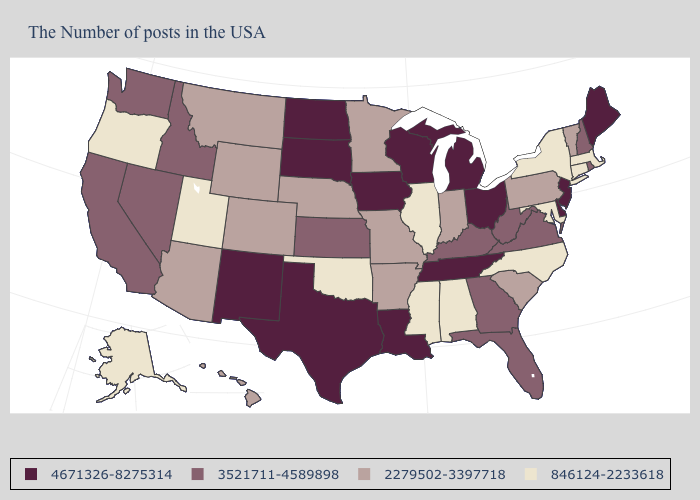What is the highest value in the South ?
Give a very brief answer. 4671326-8275314. Name the states that have a value in the range 846124-2233618?
Give a very brief answer. Massachusetts, Connecticut, New York, Maryland, North Carolina, Alabama, Illinois, Mississippi, Oklahoma, Utah, Oregon, Alaska. What is the highest value in the USA?
Concise answer only. 4671326-8275314. Name the states that have a value in the range 846124-2233618?
Short answer required. Massachusetts, Connecticut, New York, Maryland, North Carolina, Alabama, Illinois, Mississippi, Oklahoma, Utah, Oregon, Alaska. Does the map have missing data?
Write a very short answer. No. What is the value of Oklahoma?
Keep it brief. 846124-2233618. What is the value of Tennessee?
Be succinct. 4671326-8275314. Is the legend a continuous bar?
Answer briefly. No. Does Nebraska have a higher value than Alaska?
Keep it brief. Yes. Which states have the highest value in the USA?
Keep it brief. Maine, New Jersey, Delaware, Ohio, Michigan, Tennessee, Wisconsin, Louisiana, Iowa, Texas, South Dakota, North Dakota, New Mexico. What is the lowest value in the South?
Write a very short answer. 846124-2233618. What is the value of New Mexico?
Write a very short answer. 4671326-8275314. Name the states that have a value in the range 3521711-4589898?
Concise answer only. Rhode Island, New Hampshire, Virginia, West Virginia, Florida, Georgia, Kentucky, Kansas, Idaho, Nevada, California, Washington. What is the value of Missouri?
Write a very short answer. 2279502-3397718. Among the states that border Ohio , does Pennsylvania have the lowest value?
Give a very brief answer. Yes. 